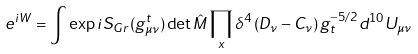Convert formula to latex. <formula><loc_0><loc_0><loc_500><loc_500>e ^ { i W } = \int \exp { i S _ { G r } ( g ^ { t } _ { \mu \nu } ) } \det \hat { M } \prod _ { x } \delta ^ { 4 } \left ( D _ { \nu } - C _ { \nu } \right ) g _ { t } ^ { - 5 / 2 } d ^ { 1 0 } U _ { \mu \nu }</formula> 